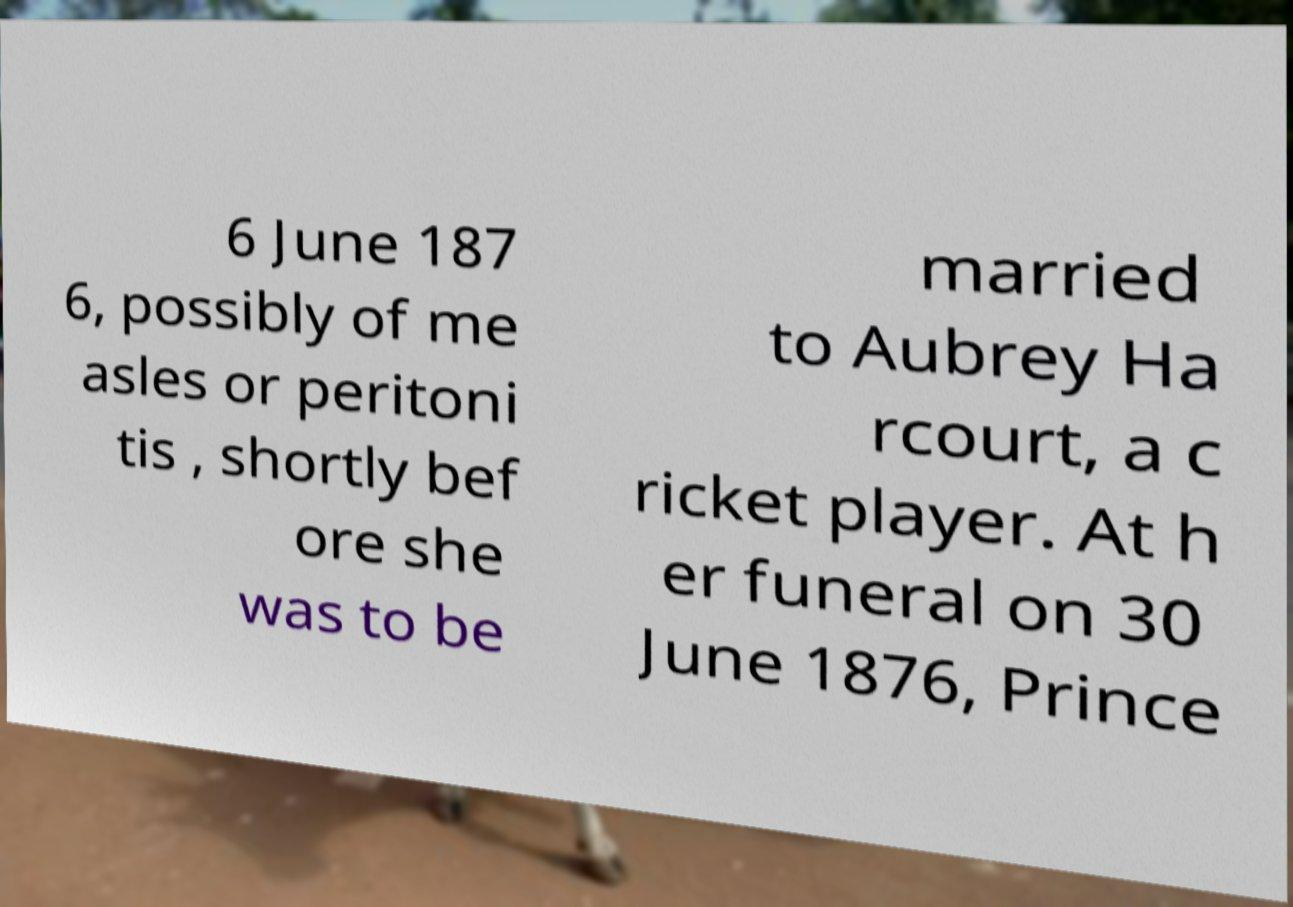Could you assist in decoding the text presented in this image and type it out clearly? 6 June 187 6, possibly of me asles or peritoni tis , shortly bef ore she was to be married to Aubrey Ha rcourt, a c ricket player. At h er funeral on 30 June 1876, Prince 